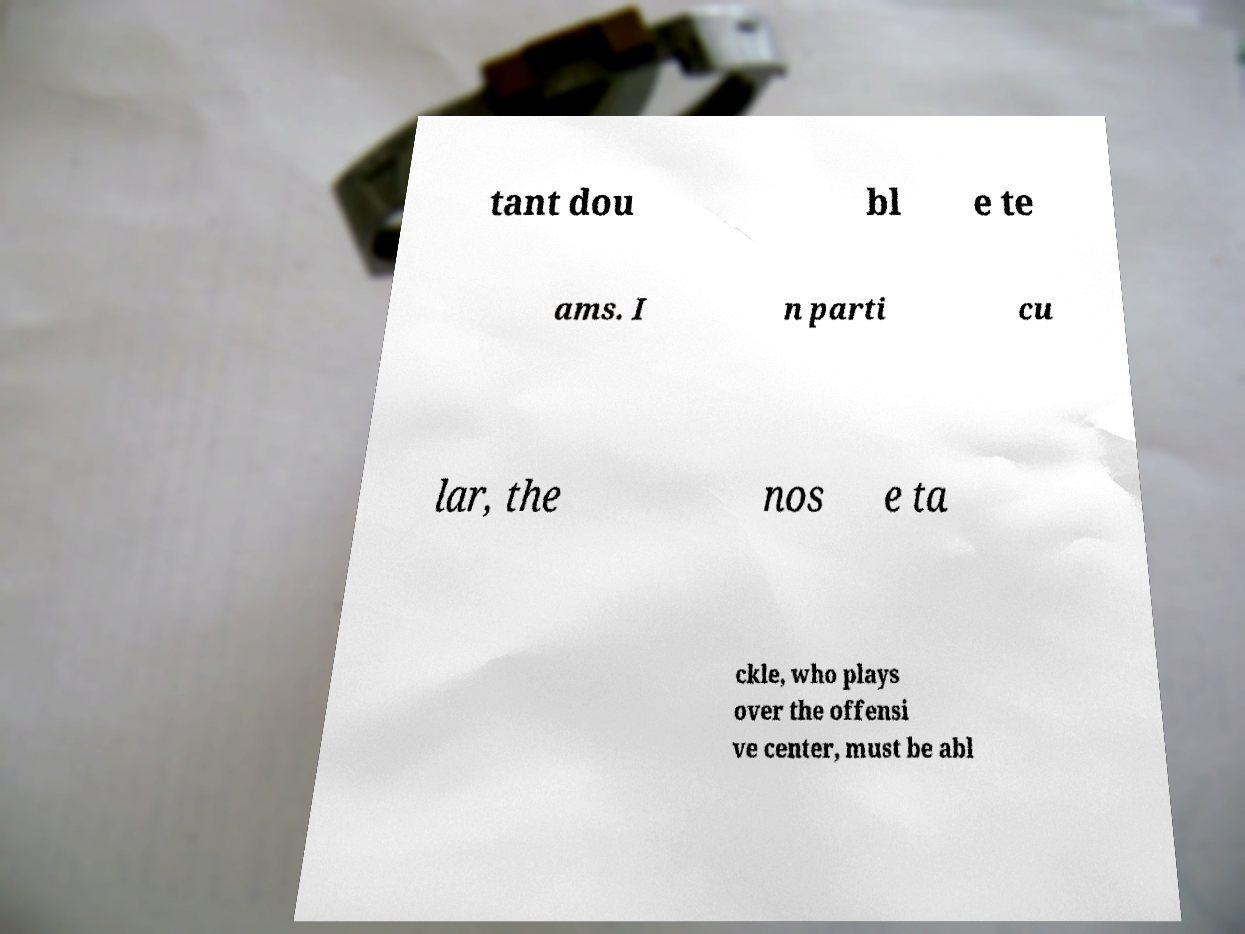For documentation purposes, I need the text within this image transcribed. Could you provide that? tant dou bl e te ams. I n parti cu lar, the nos e ta ckle, who plays over the offensi ve center, must be abl 